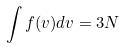<formula> <loc_0><loc_0><loc_500><loc_500>\int f ( v ) d v = 3 N</formula> 